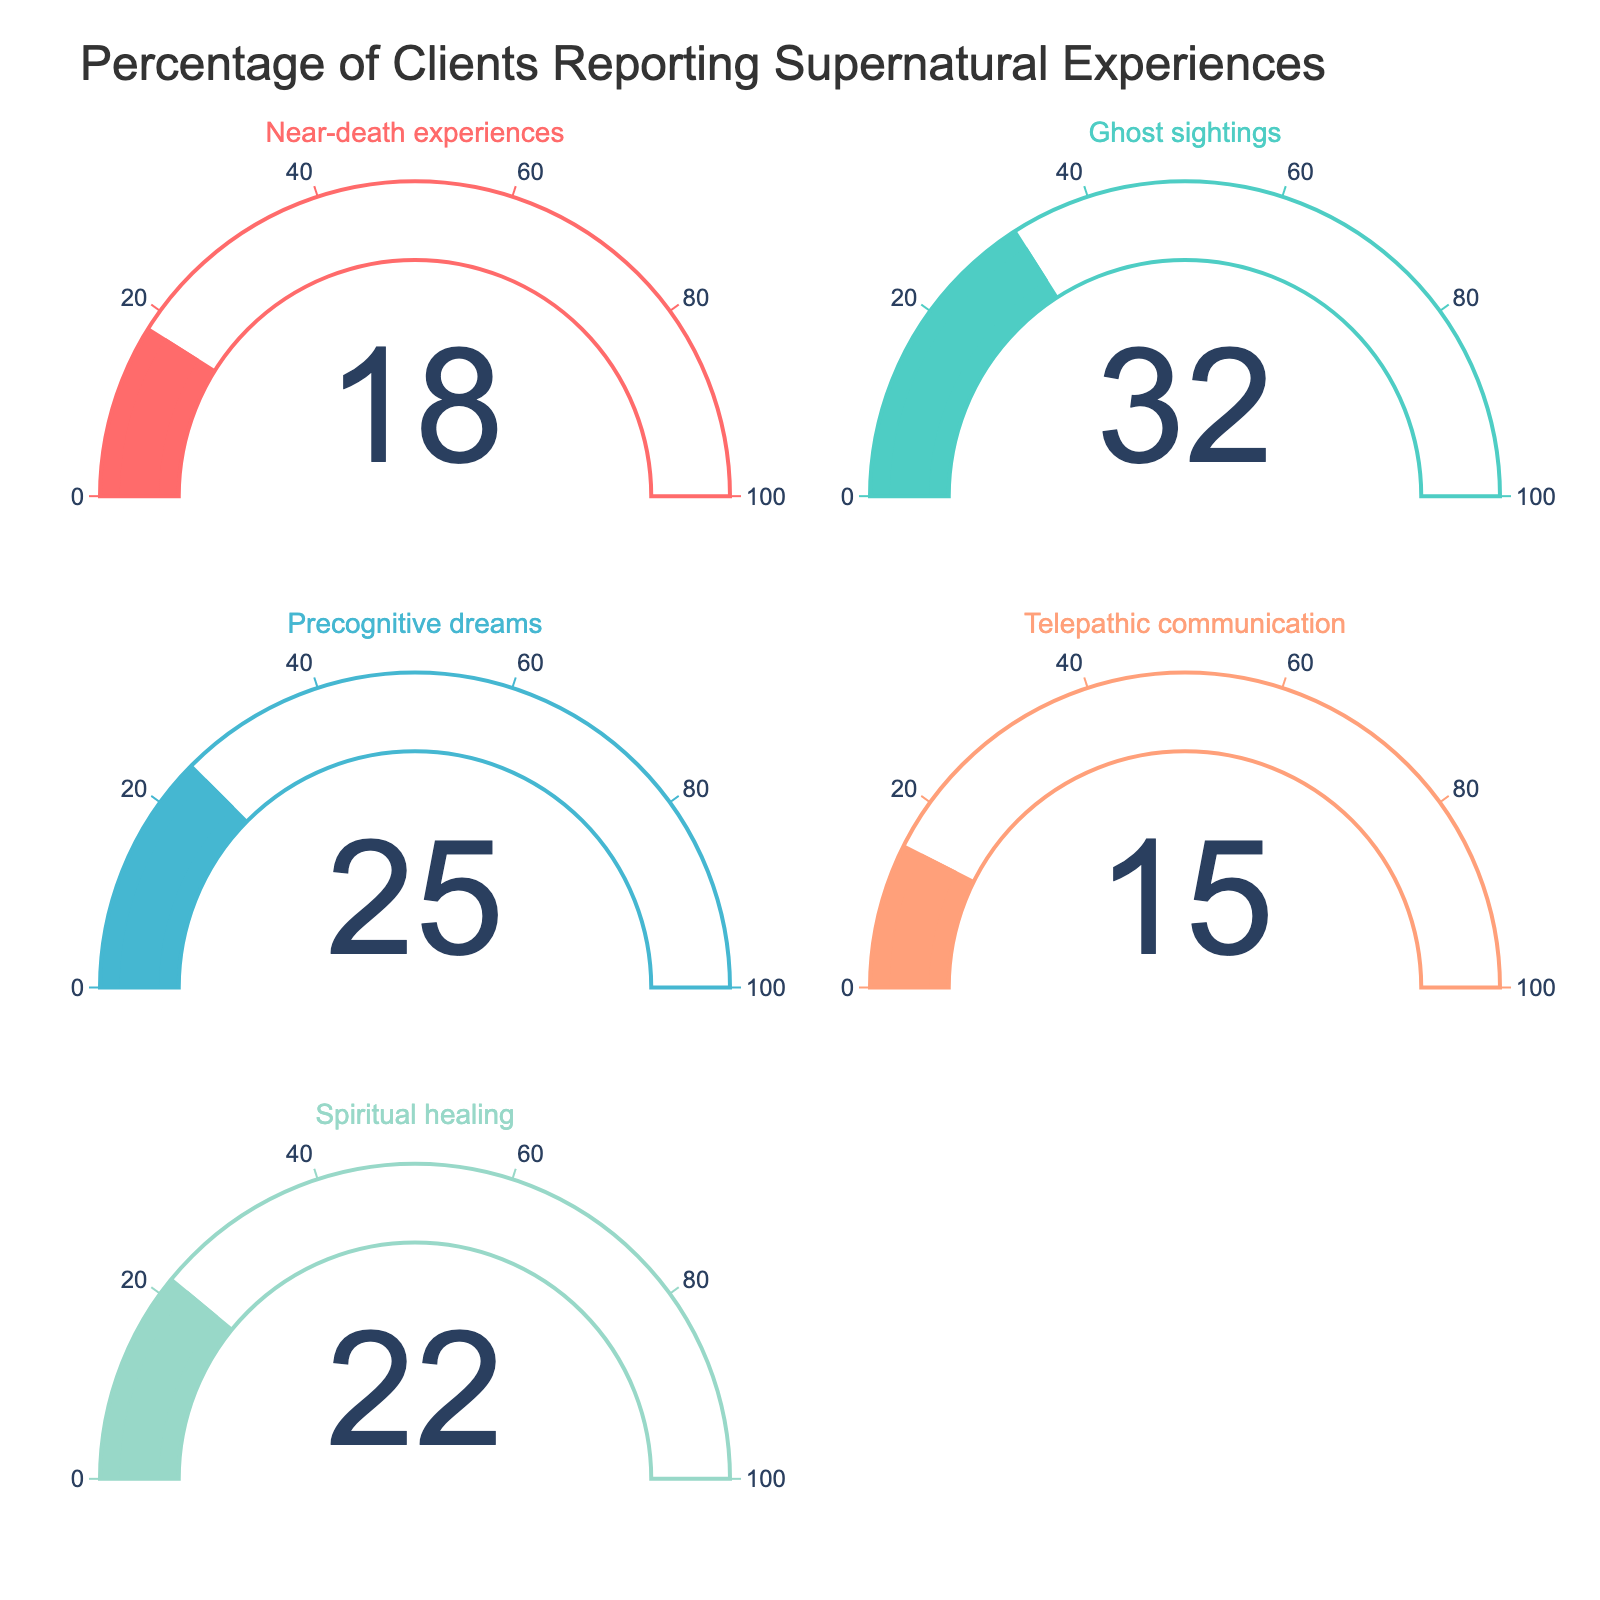What is the percentage of clients reporting ghost sightings? Look at the gauge labeled "Ghost sightings". The number displayed is 32.
Answer: 32 Which category has the highest percentage of clients reporting supernatural experiences? Compare the values displayed on all the gauges. The gauge with the highest value is "Ghost sightings" at 32.
Answer: Ghost sightings What is the sum of the percentages for telepathic communication and precognitive dreams? Check the gauges for "Telepathic communication" and "Precognitive dreams". The values are 15 and 25, respectively. Add them together: 15 + 25 = 40.
Answer: 40 Are there more clients reporting spiritual healing or near-death experiences? Compare the values for "Spiritual healing" and "Near-death experiences". "Spiritual healing" has 22, and "Near-death experiences" has 18.
Answer: Spiritual healing What's the average percentage of clients reporting supernatural experiences across all categories? Sum all percentages: 18 (Near-death) + 32 (Ghost sightings) + 25 (Precognitive dreams) + 15 (Telepathic communication) + 22 (Spiritual healing) = 112. Divide by the number of categories, which is 5: 112/5 = 22.4.
Answer: 22.4 Which category has the lowest percentage of clients reporting supernatural experiences? Compare the values on all gauges. The lowest value is "Telepathic communication" at 15.
Answer: Telepathic communication What is the difference in percentages between ghost sightings and near-death experiences? Check the values for "Ghost sightings" (32) and "Near-death experiences" (18). Subtract the smaller from the larger: 32 - 18 = 14.
Answer: 14 What is the combined percentage of clients reporting spiritual healing and ghost sightings? Add the percentages displayed for "Spiritual healing" (22) and "Ghost sightings" (32): 22 + 32 = 54.
Answer: 54 Is the percentage of clients reporting precognitive dreams higher or lower than those reporting spiritual healing? Compare the values for "Precognitive dreams" (25) and "Spiritual healing" (22). "Precognitive dreams" has a higher value.
Answer: Higher What is the range of percentages reported across all categories? Determine the smallest and largest percentages: "Telepathic communication" (15) and "Ghost sightings" (32). Subtract the smallest from the largest: 32 - 15 = 17.
Answer: 17 